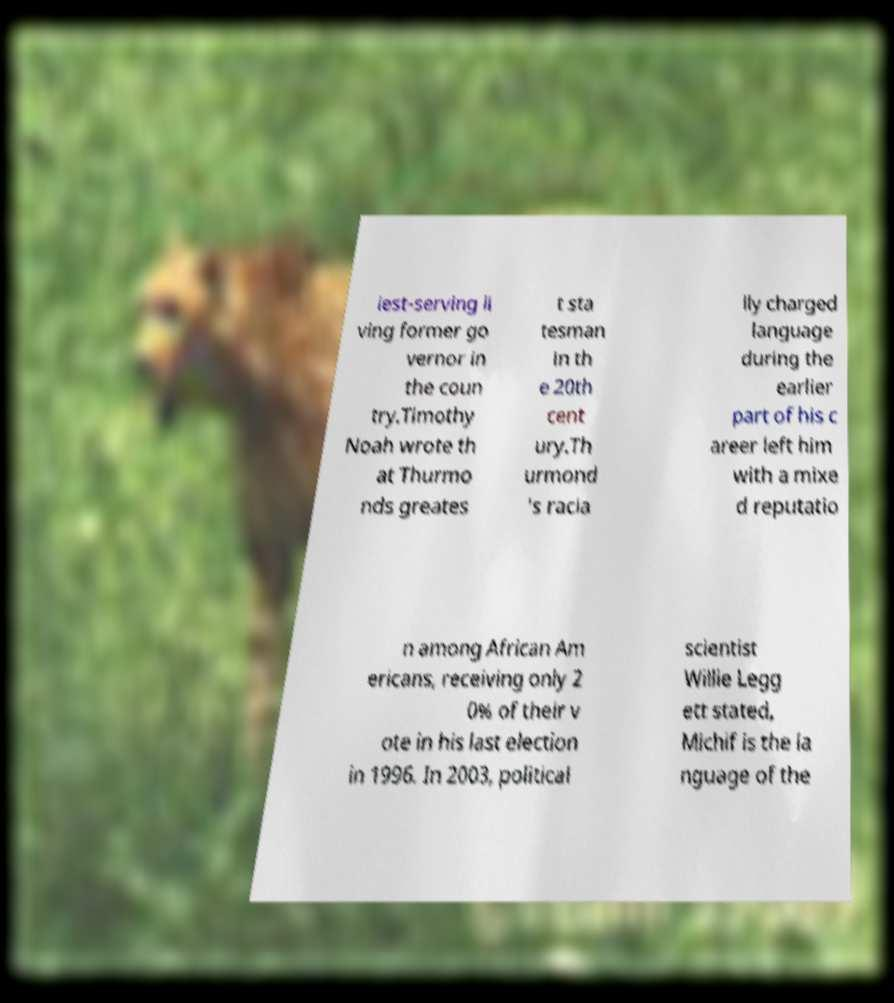What messages or text are displayed in this image? I need them in a readable, typed format. iest-serving li ving former go vernor in the coun try.Timothy Noah wrote th at Thurmo nds greates t sta tesman in th e 20th cent ury.Th urmond 's racia lly charged language during the earlier part of his c areer left him with a mixe d reputatio n among African Am ericans, receiving only 2 0% of their v ote in his last election in 1996. In 2003, political scientist Willie Legg ett stated, Michif is the la nguage of the 